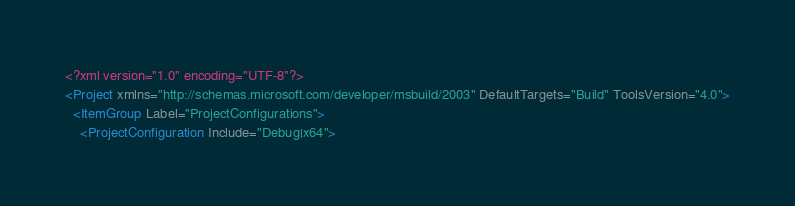<code> <loc_0><loc_0><loc_500><loc_500><_XML_><?xml version="1.0" encoding="UTF-8"?>
<Project xmlns="http://schemas.microsoft.com/developer/msbuild/2003" DefaultTargets="Build" ToolsVersion="4.0">
  <ItemGroup Label="ProjectConfigurations">
    <ProjectConfiguration Include="Debug|x64"></code> 